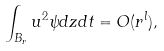<formula> <loc_0><loc_0><loc_500><loc_500>\int _ { B _ { r } } u ^ { 2 } \psi d z d t = O ( r ^ { l } ) , \</formula> 